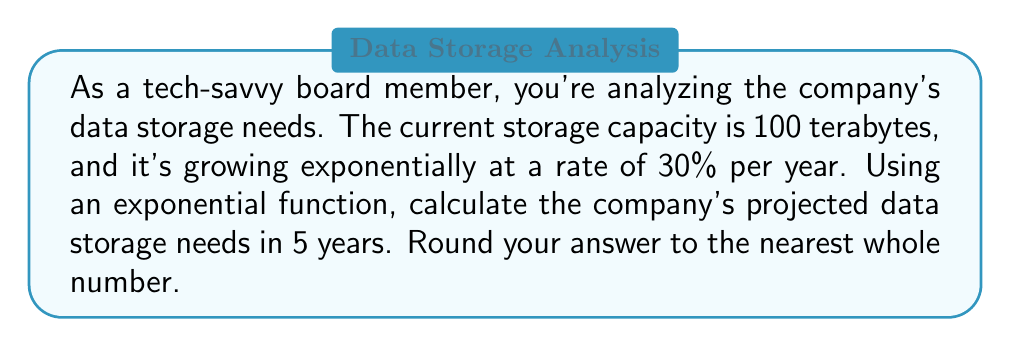Give your solution to this math problem. Let's approach this step-by-step:

1) The exponential growth function is given by:
   $$A(t) = A_0 \cdot (1 + r)^t$$
   where:
   $A(t)$ is the amount after time $t$
   $A_0$ is the initial amount
   $r$ is the growth rate (as a decimal)
   $t$ is the time period

2) In this case:
   $A_0 = 100$ terabytes
   $r = 30\% = 0.30$
   $t = 5$ years

3) Plugging these values into our equation:
   $$A(5) = 100 \cdot (1 + 0.30)^5$$

4) Simplify:
   $$A(5) = 100 \cdot (1.30)^5$$

5) Calculate:
   $$A(5) = 100 \cdot 3.71293$$
   $$A(5) = 371.293$$

6) Rounding to the nearest whole number:
   $$A(5) \approx 371$$ terabytes

This exponential growth model shows that the company's data storage needs will more than triple in just 5 years, emphasizing the importance of planning for rapid expansion in storage infrastructure.
Answer: 371 terabytes 